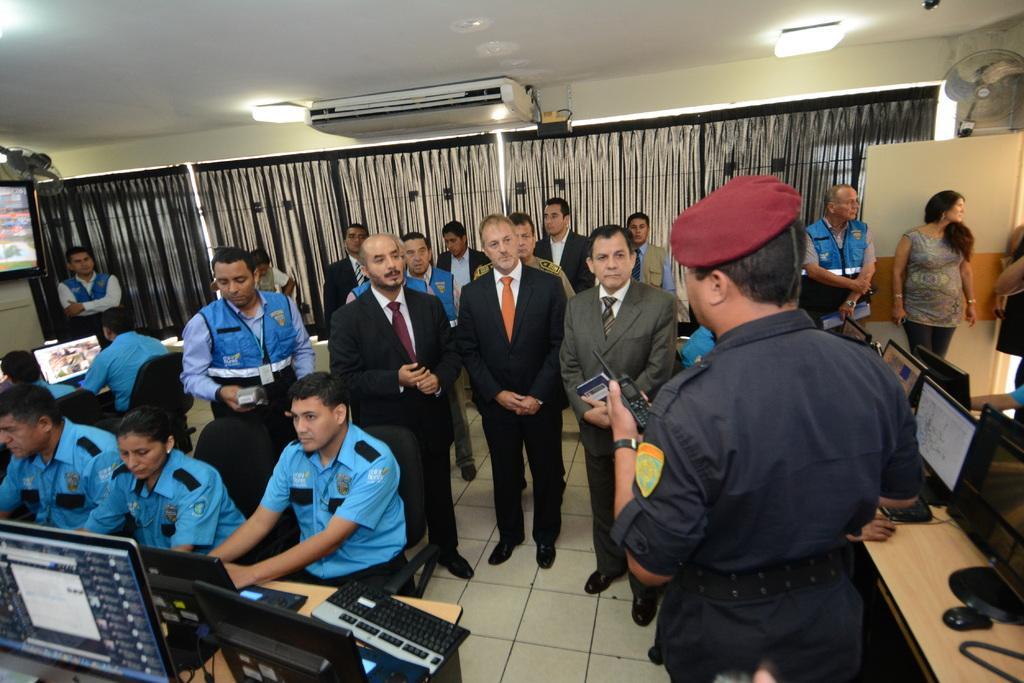Please provide a concise description of this image. This picture describes about group of people, few are seated on the chairs and few are standing, in front of them we can see few monitors, key boards and other things on the tables, in the background we can see few curtains, lights, fans, air conditioner and a digital screen. 